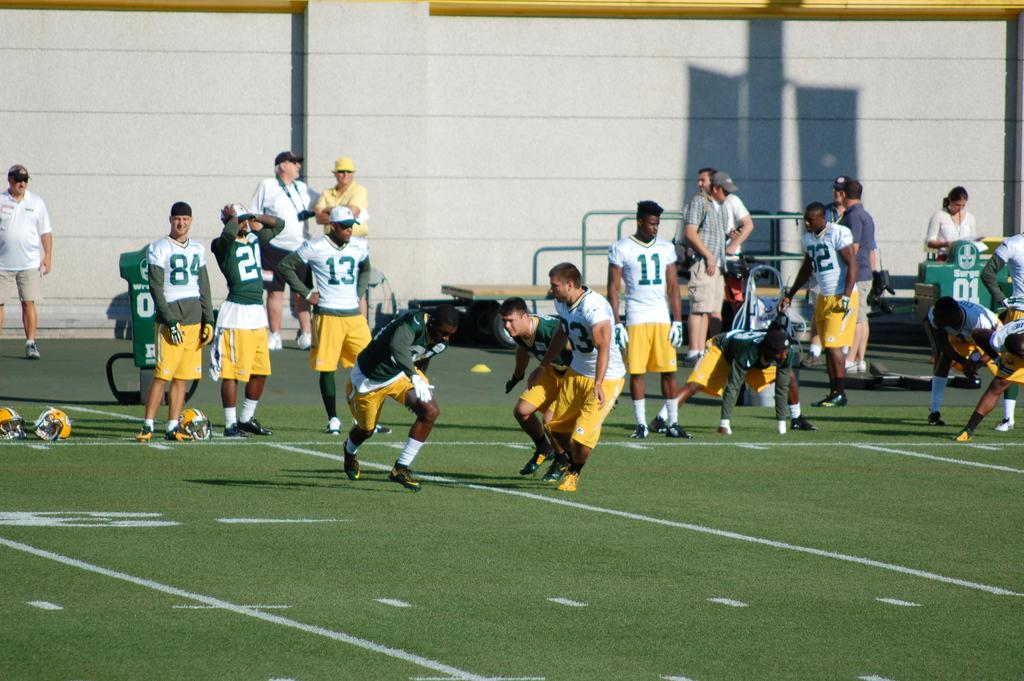Provide a one-sentence caption for the provided image. A soccer game between two teams with jerseys that say13. 